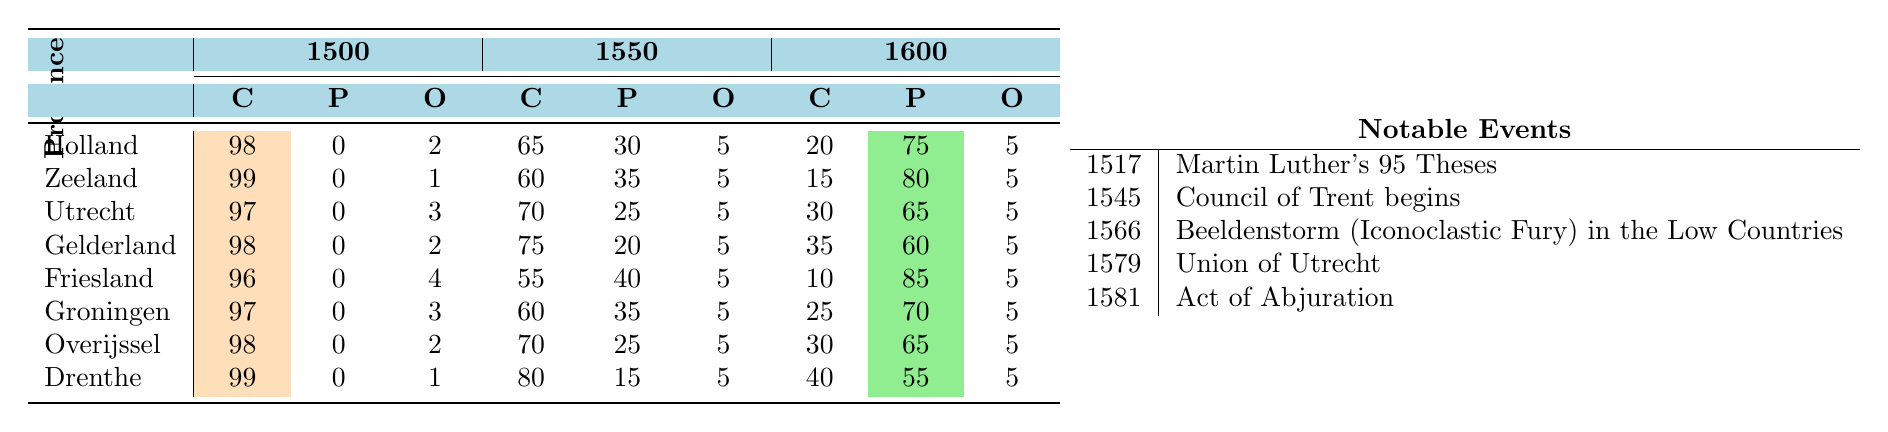What was the percentage of Catholics in Holland in 1500? According to the table, the value for Catholics in Holland in 1500 is 98%.
Answer: 98% What province had the highest percentage of Protestants in 1600? In the table, Friesland has the highest percentage of Protestants at 85% in 1600.
Answer: Friesland What percentage of the population in Zeeland was Other in 1550? The table indicates that in Zeeland 5% of the population was categorized as Other in 1550.
Answer: 5% What was the difference in the percentage of Catholics in Drenthe from 1500 to 1600? In Drenthe, the percentage of Catholics decreased from 99% in 1500 to 40% in 1600. Thus, the difference is 99% - 40% = 59%.
Answer: 59% Which province saw the largest increase in Protestant percentage between 1500 and 1600? Calculating the increases: Holland (75%), Zeeland (80%), Utrecht (65%), Gelderland (60%), Friesland (85%), Groningen (70%), Overijssel (65%), Drenthe (55%). The largest increase is in Friesland from 0% to 85%, so 85% is the largest increase.
Answer: Friesland Did Utrecht have more Protestants than Gelderland in 1550? According to the table, Utrecht had 25% Protestants while Gelderland had 20% in 1550. Therefore, it is true that Utrecht had more.
Answer: Yes What is the average percentage of Catholics across all provinces in 1500? The sum of the percentages of Catholics in 1500 is (98 + 99 + 97 + 98 + 96 + 97 + 98 + 99) = 784. There are 8 provinces, so the average is 784 / 8 = 98%.
Answer: 98% What was the percentage of Catholics in Friesland in 1550 compared to 1500? In Friesland, the percentage of Catholics in 1500 was 96%, and in 1550 it was 55%. The reduction is 96% - 55% = 41%.
Answer: 41% If we consider the change from 1500 to 1600, which province retained the highest percentage of Catholics in 1600? In 1600, the percentages of Catholics were: Holland (20%), Zeeland (15%), Utrecht (30%), Gelderland (35%), Friesland (10%), Groningen (25%), Overijssel (30%), Drenthe (40%). Drenthe retains the highest at 40%.
Answer: Drenthe How many provinces had less than 50% Catholics in 1600? Analyzing the percentages in 1600: Holland (20%), Zeeland (15%), Friesland (10%), Gelderland (35%), Groningen (25%), and the provinces with more than 50% are Utrecht (30%), Overijssel (30%), and Drenthe (40%), resulting in four provinces with less than 50%.
Answer: 4 